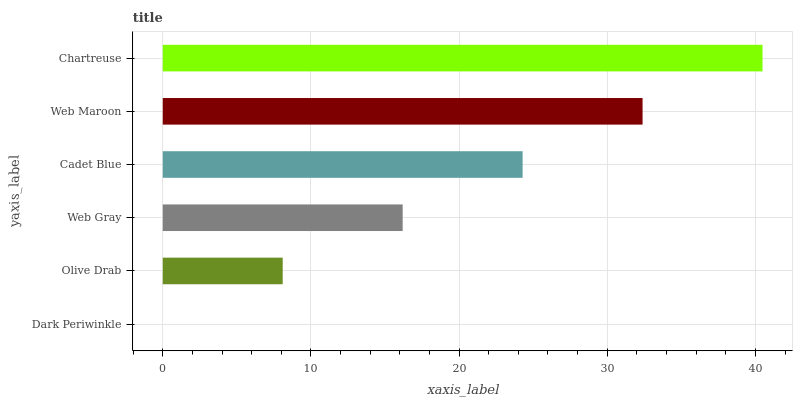Is Dark Periwinkle the minimum?
Answer yes or no. Yes. Is Chartreuse the maximum?
Answer yes or no. Yes. Is Olive Drab the minimum?
Answer yes or no. No. Is Olive Drab the maximum?
Answer yes or no. No. Is Olive Drab greater than Dark Periwinkle?
Answer yes or no. Yes. Is Dark Periwinkle less than Olive Drab?
Answer yes or no. Yes. Is Dark Periwinkle greater than Olive Drab?
Answer yes or no. No. Is Olive Drab less than Dark Periwinkle?
Answer yes or no. No. Is Cadet Blue the high median?
Answer yes or no. Yes. Is Web Gray the low median?
Answer yes or no. Yes. Is Chartreuse the high median?
Answer yes or no. No. Is Olive Drab the low median?
Answer yes or no. No. 